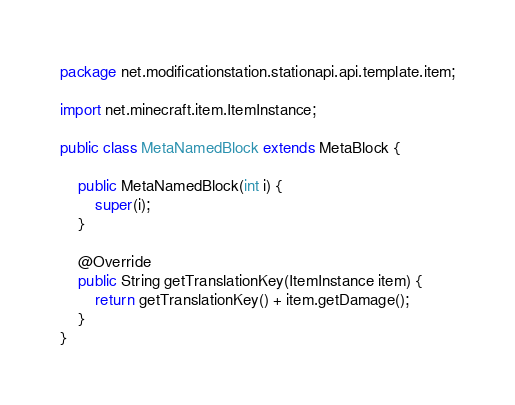Convert code to text. <code><loc_0><loc_0><loc_500><loc_500><_Java_>package net.modificationstation.stationapi.api.template.item;

import net.minecraft.item.ItemInstance;

public class MetaNamedBlock extends MetaBlock {

    public MetaNamedBlock(int i) {
        super(i);
    }

    @Override
    public String getTranslationKey(ItemInstance item) {
        return getTranslationKey() + item.getDamage();
    }
}
</code> 